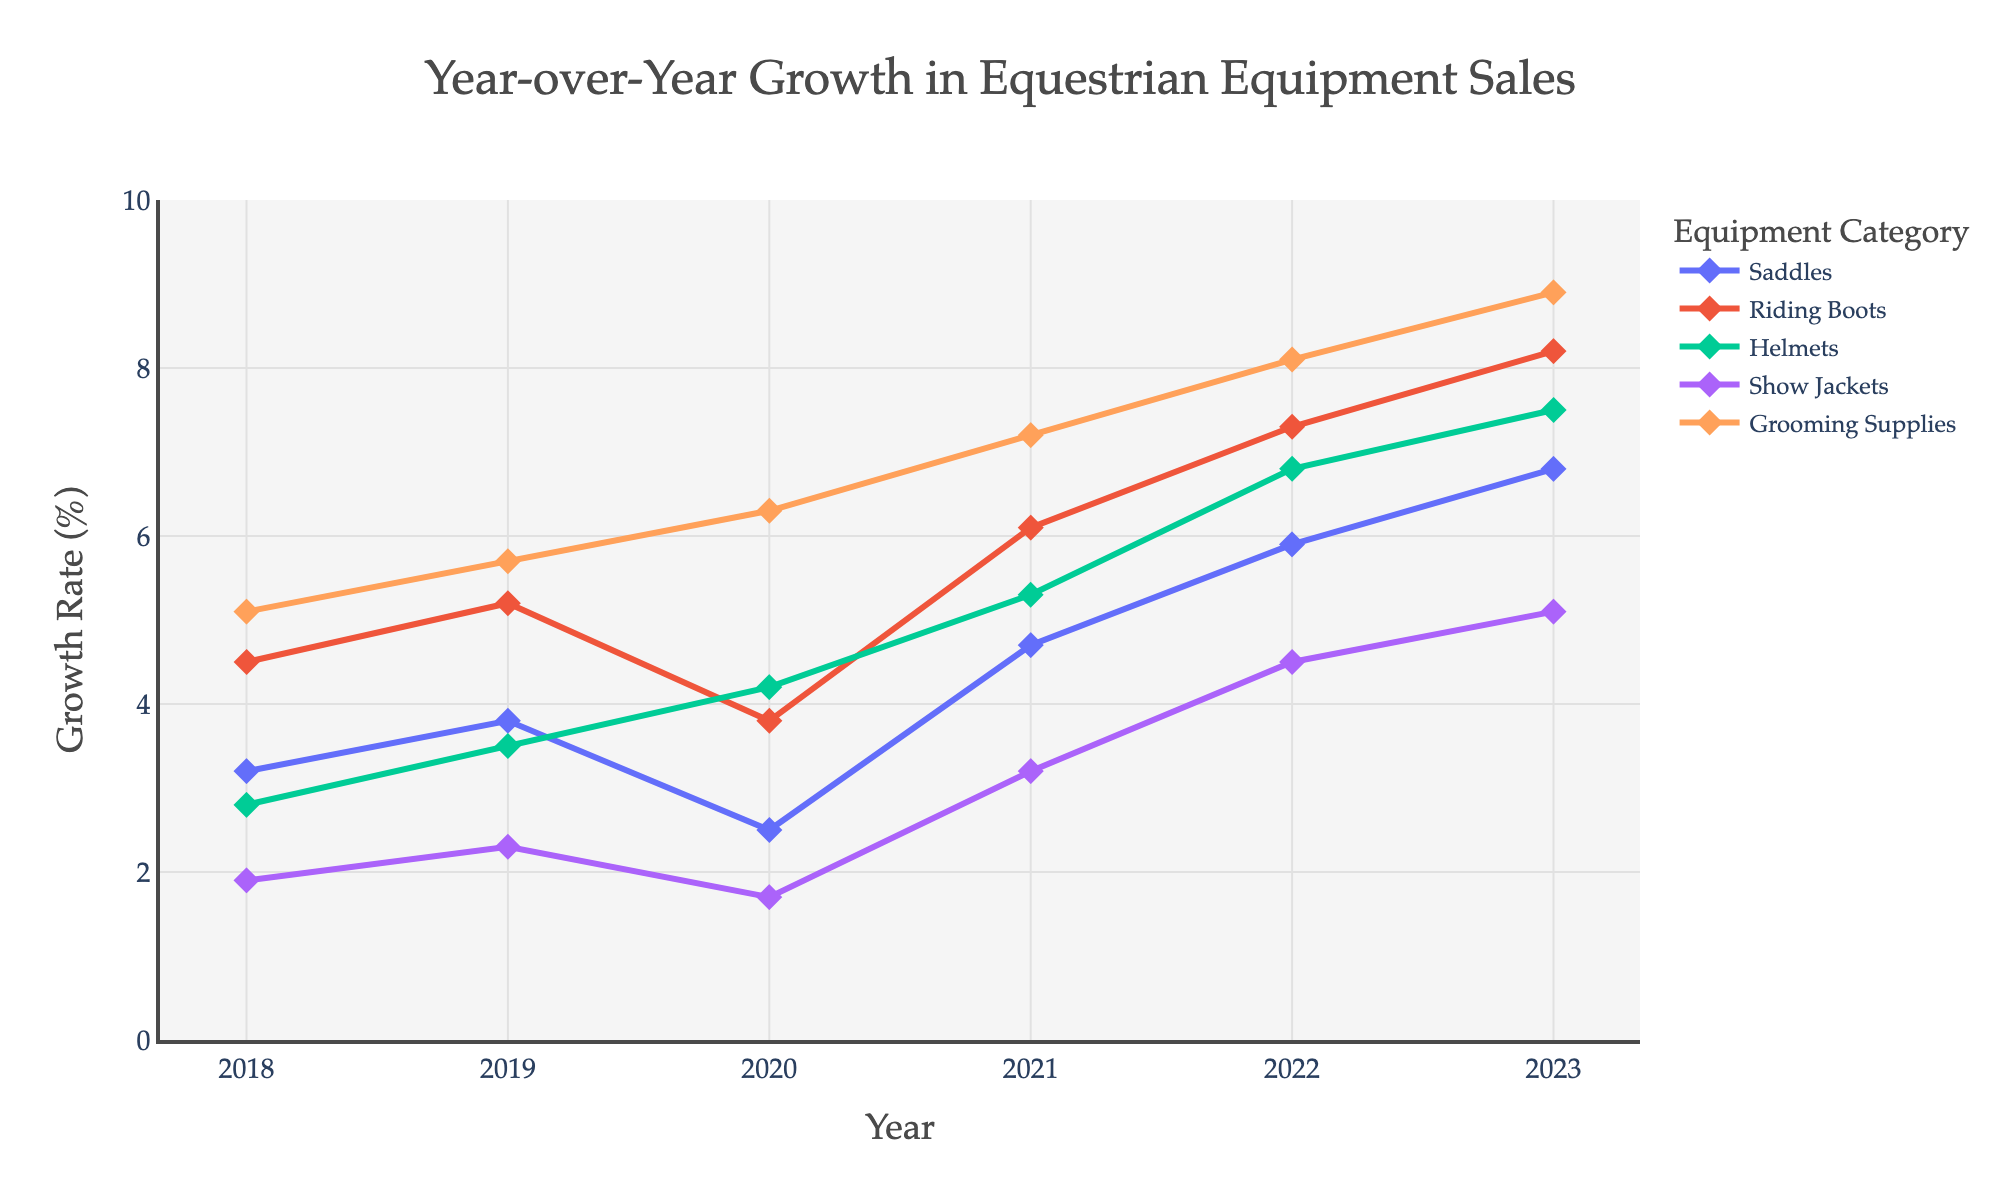What's the growth rate of Riding Boots in 2020? Referring to the line chart, look for the year 2020 along the x-axis and find the corresponding value for Riding Boots on the y-axis.
Answer: 3.8% Which equipment category had the highest growth rate in 2021? Referring to the line chart, find the values for all categories in the year 2021 and identify the maximum value.
Answer: Grooming Supplies Compare the growth rate of Helmets and Show Jackets in 2022. Which one was greater? Look at the values for Helmets and Show Jackets in the year 2022 and compare them.
Answer: Helmets What is the average growth rate of Saddles from 2018 to 2023? Add the growth rates of Saddles from 2018 to 2023 and divide by the number of years (6).
Answer: 4.48% Was the growth rate of Show Jackets ever higher than that of Saddles? If yes, in which year(s)? Compare the growth rates of Show Jackets and Saddles for each year. Identify the year(s) where Show Jackets had a higher growth rate.
Answer: 2023 Which category had the least growth in 2019? Look at the values in the year 2019 for all categories and identify the minimum value.
Answer: Show Jackets What is the trend of Grooming Supplies from 2018 to 2023? Examine the plot line for Grooming Supplies and observe the overall direction from 2018 to 2023.
Answer: Increasing Calculate the difference in the growth rate of Saddles between 2018 and 2022. Subtract the value of Saddles in 2018 from its value in 2022.
Answer: 2.7% Which two categories showed the highest increase in growth rate between 2020 and 2021? Calculate the difference between 2020 and 2021 values for each category and identify the two highest differences.
Answer: Saddles and Show Jackets 